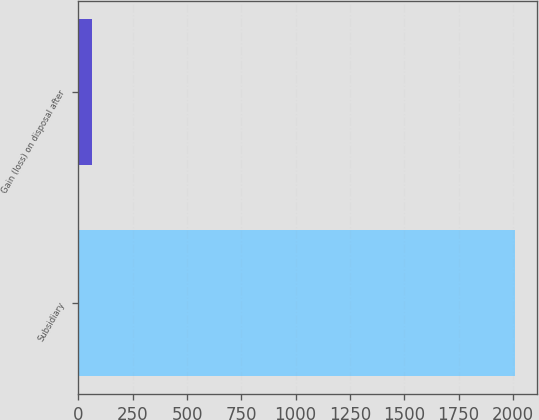Convert chart. <chart><loc_0><loc_0><loc_500><loc_500><bar_chart><fcel>Subsidiary<fcel>Gain (loss) on disposal after<nl><fcel>2010<fcel>64<nl></chart> 